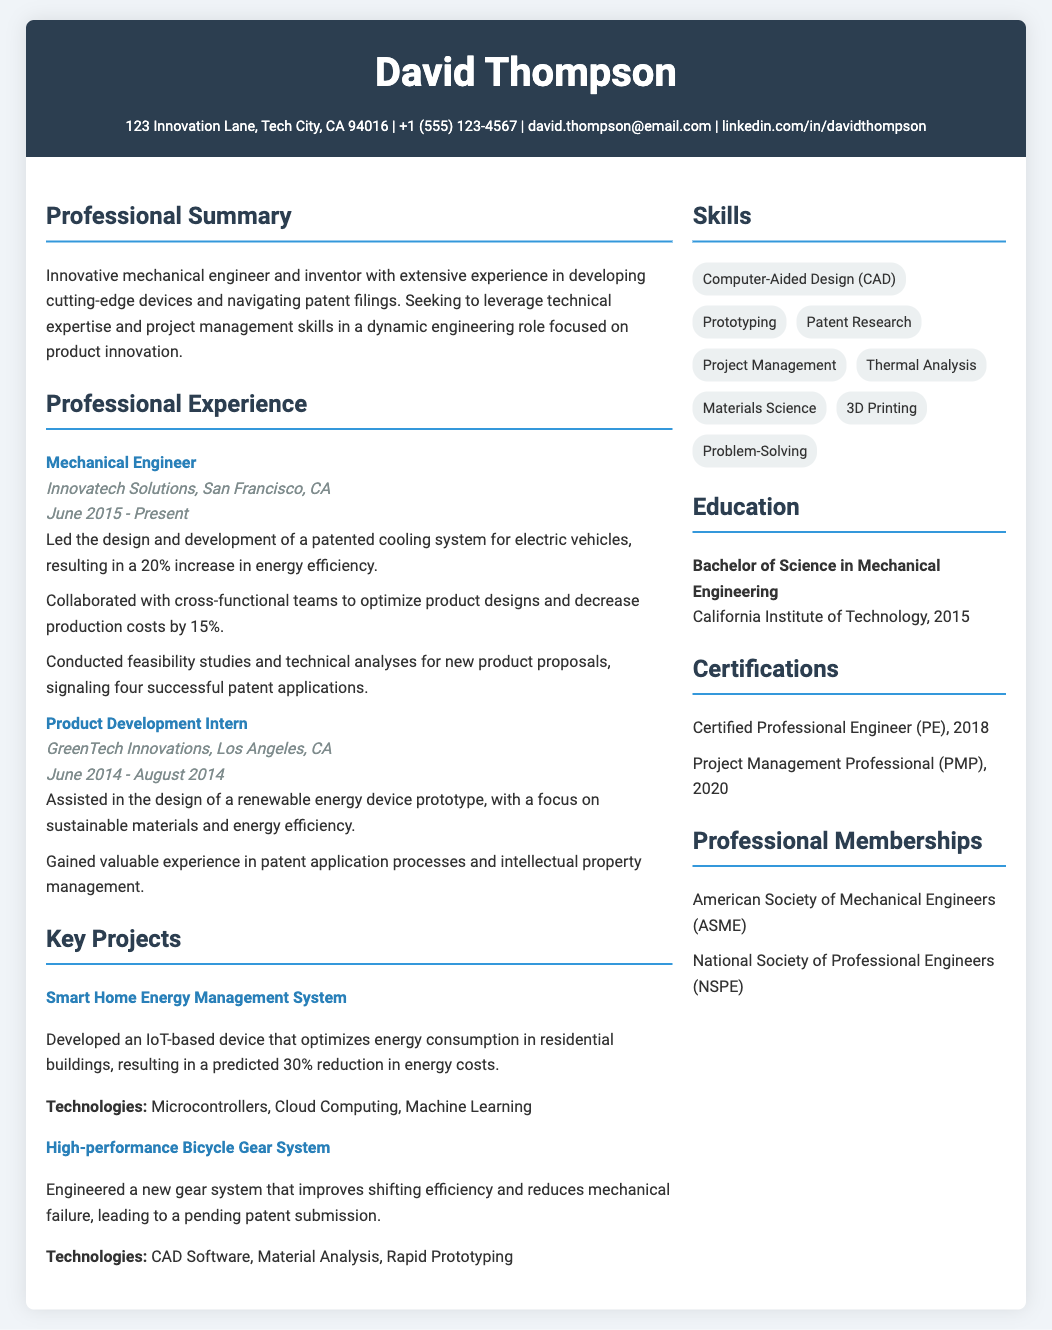What is the name of the individual in the resume? The name of the individual is prominently displayed at the top under the header section.
Answer: David Thompson What university did David Thompson attend? The educational background is mentioned in the Education section specifying the university name.
Answer: California Institute of Technology How many years of experience in the current role? The Professional Experience section lists the dates to determine the duration of employment in the current role.
Answer: 8 years What technology was used in the Smart Home Energy Management System project? The technologies applied in the key projects are listed after each project description.
Answer: Microcontrollers, Cloud Computing, Machine Learning What was the role of David Thompson at GreenTech Innovations? The Professional Experience section indicates the job title he held at that company.
Answer: Product Development Intern How many certifications does David Thompson have? The Certifications section outlines the number of certifications currently held.
Answer: 2 Which professional membership is mentioned in the resume? The Professional Memberships section lists the organizations of which David is a member.
Answer: American Society of Mechanical Engineers (ASME) What percentage increase in energy efficiency did the patented cooling system achieve? The specific achievement from the development of the cooling system is mentioned in the Professional Experience section.
Answer: 20% 